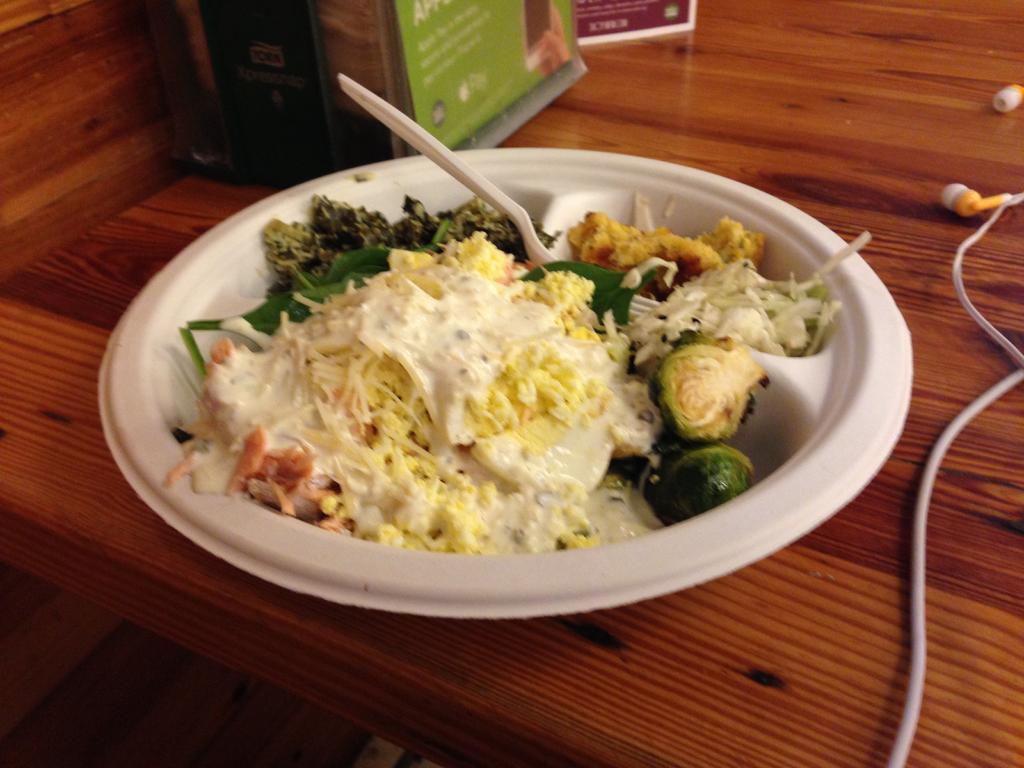Could you give a brief overview of what you see in this image? In this picture there is an edible and a fork placed in the bowl and there are some other objects beside it. 